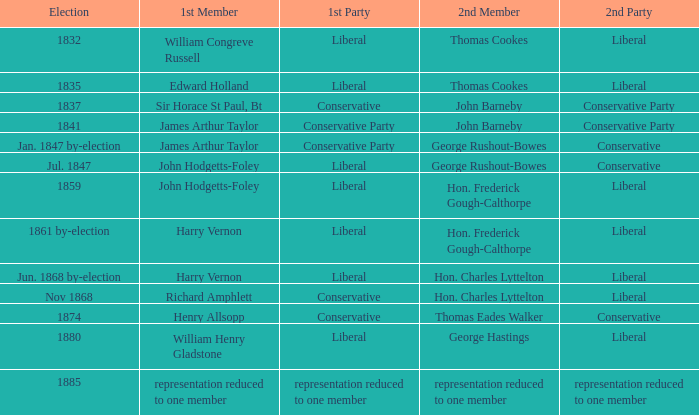What was the 2nd Party, when the 1st Member was John Hodgetts-Foley, and the 2nd Member was Hon. Frederick Gough-Calthorpe? Liberal. 